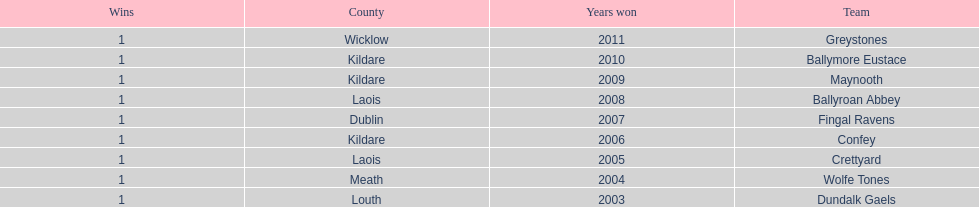What is the years won for each team 2011, 2010, 2009, 2008, 2007, 2006, 2005, 2004, 2003. 